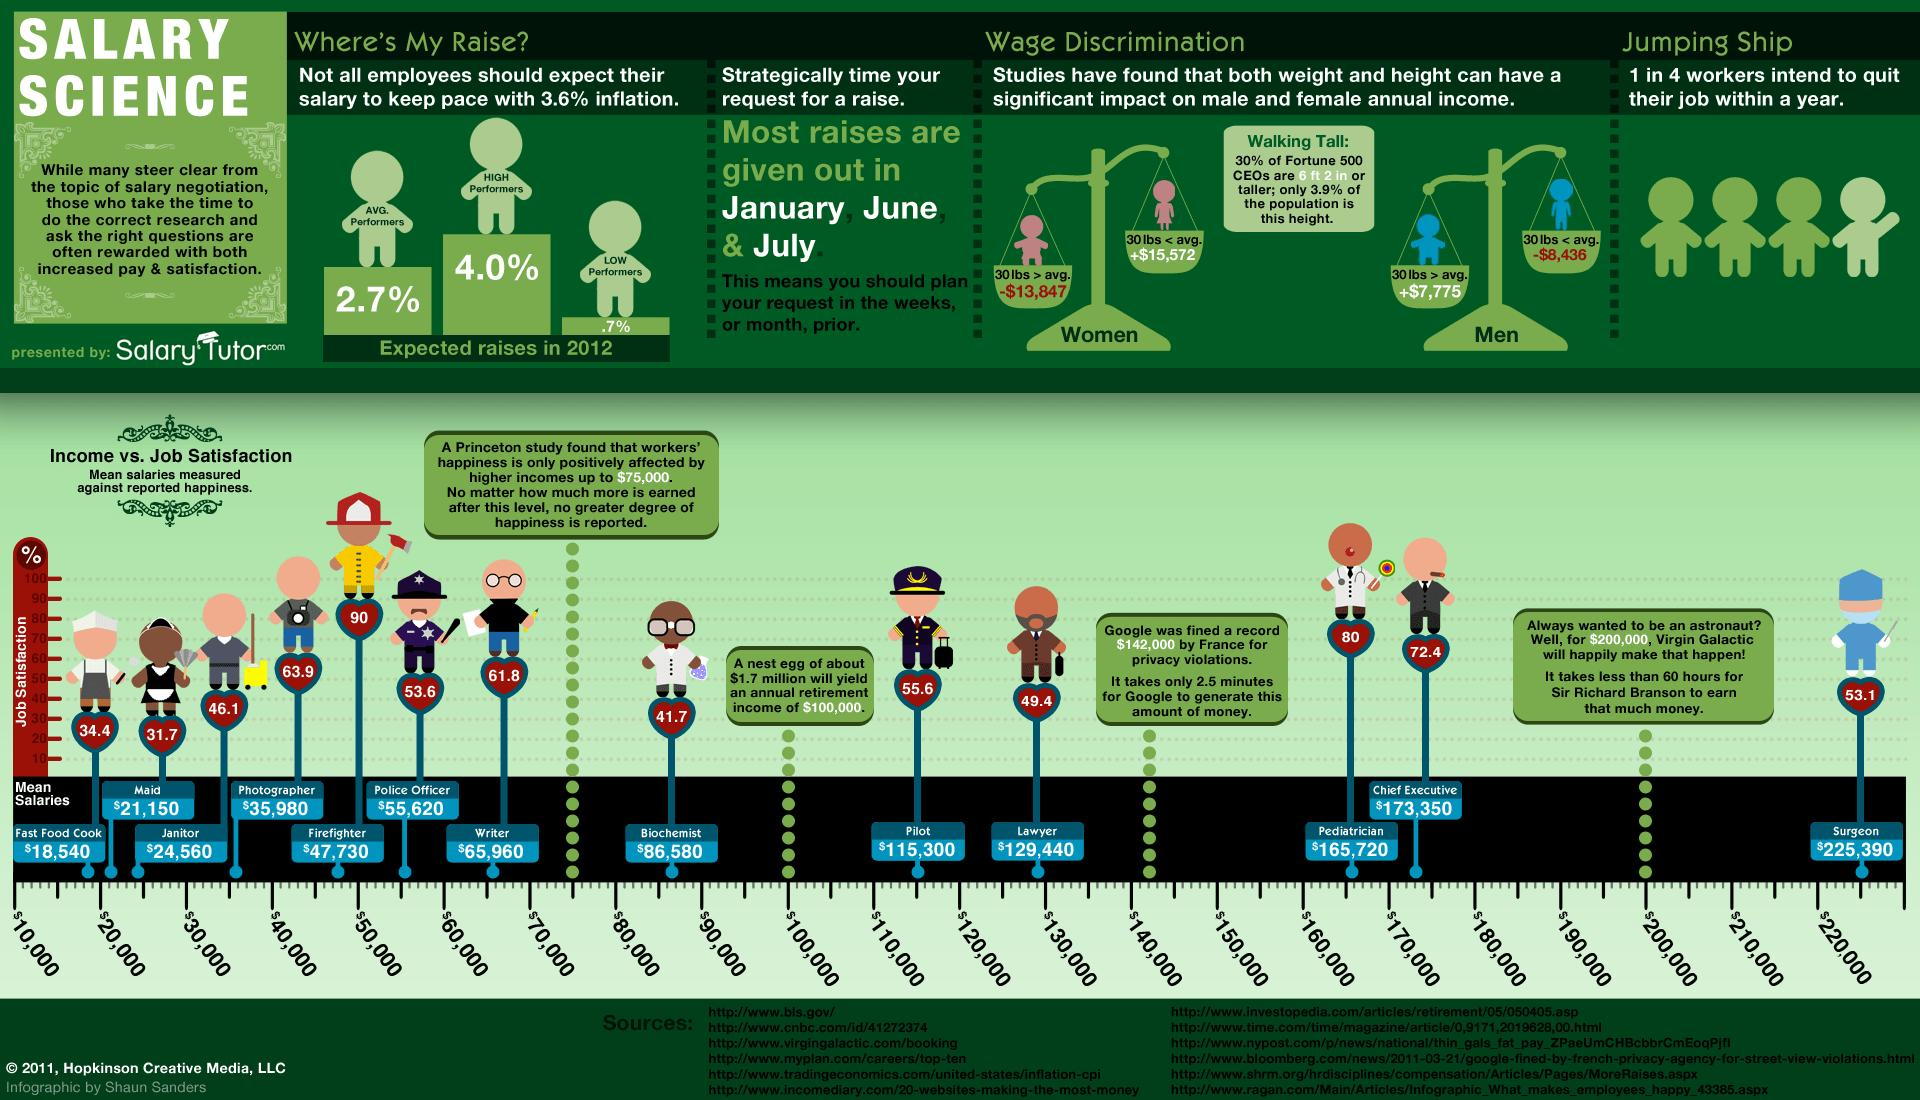Mention a couple of crucial points in this snapshot. The study found that the job satisfaction among writers is 61.8%. The mean salary of a police officer, as per a study, is $55,620. The study found that the job with the lowest satisfaction rating is that of a maid. The Princeton study revealed that surgeons are the highest paid profession, according to the results of the study. According to a study, the job satisfaction among photographers is 63.9%. 